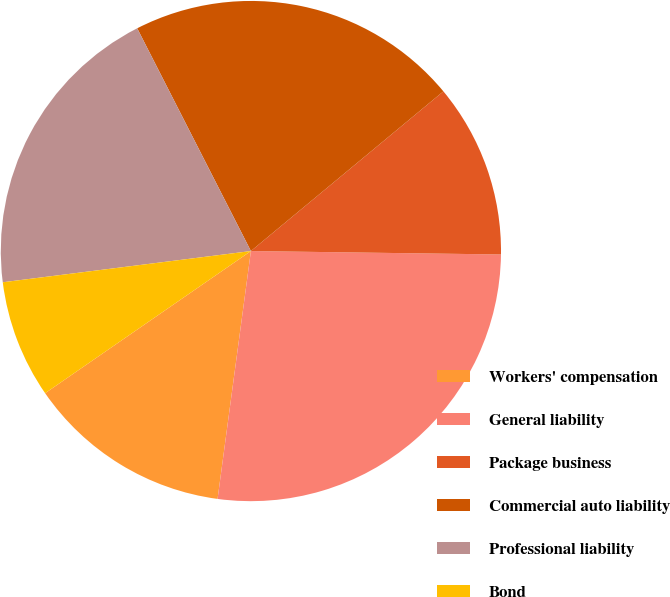<chart> <loc_0><loc_0><loc_500><loc_500><pie_chart><fcel>Workers' compensation<fcel>General liability<fcel>Package business<fcel>Commercial auto liability<fcel>Professional liability<fcel>Bond<nl><fcel>13.25%<fcel>26.91%<fcel>11.24%<fcel>21.49%<fcel>19.48%<fcel>7.63%<nl></chart> 